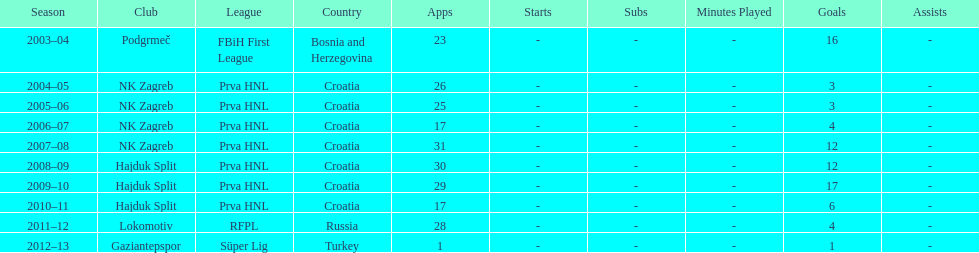What is the highest number of goals scored by senijad ibri&#269;i&#263; in a season? 35. 